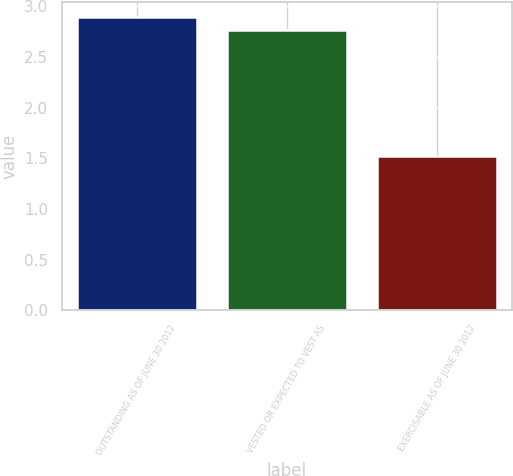Convert chart. <chart><loc_0><loc_0><loc_500><loc_500><bar_chart><fcel>OUTSTANDING AS OF JUNE 30 2012<fcel>VESTED OR EXPECTED TO VEST AS<fcel>EXERCISABLE AS OF JUNE 30 2012<nl><fcel>2.9<fcel>2.77<fcel>1.52<nl></chart> 